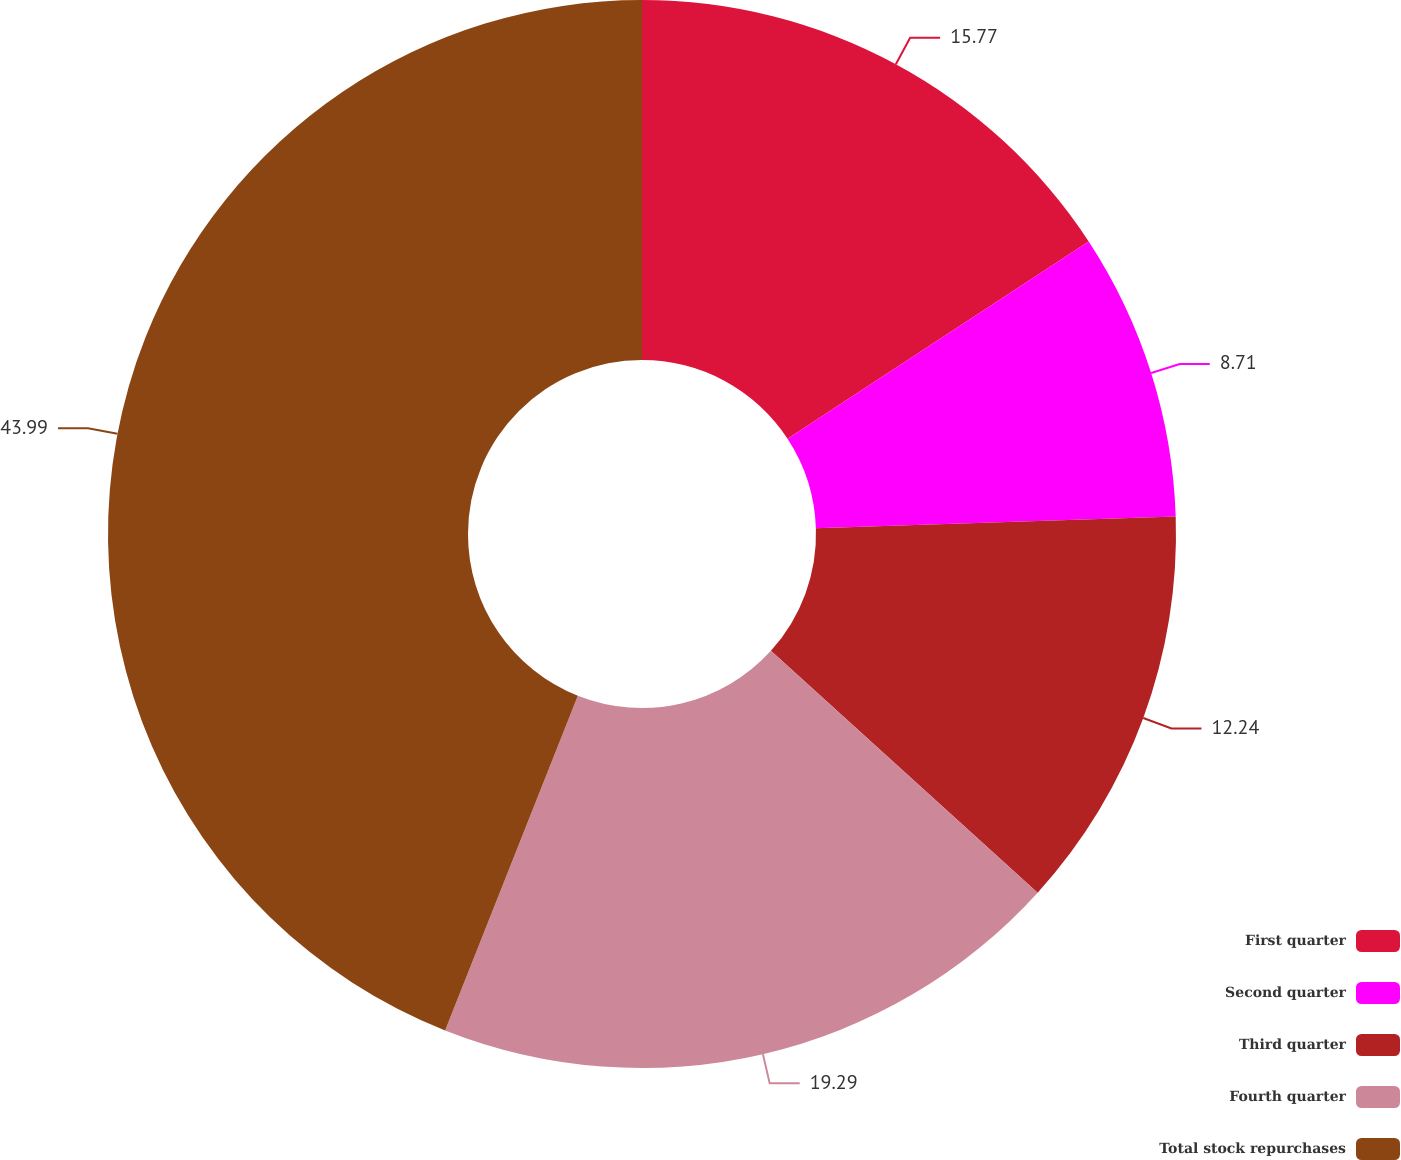Convert chart. <chart><loc_0><loc_0><loc_500><loc_500><pie_chart><fcel>First quarter<fcel>Second quarter<fcel>Third quarter<fcel>Fourth quarter<fcel>Total stock repurchases<nl><fcel>15.77%<fcel>8.71%<fcel>12.24%<fcel>19.29%<fcel>43.99%<nl></chart> 